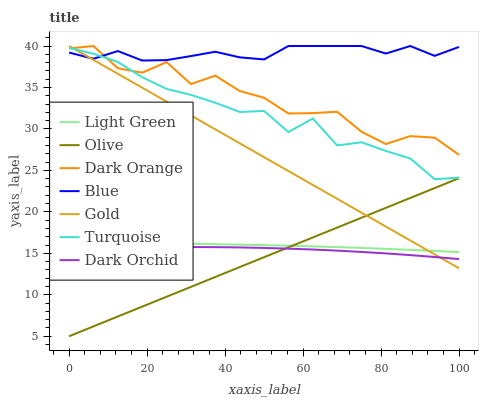Does Olive have the minimum area under the curve?
Answer yes or no. Yes. Does Blue have the maximum area under the curve?
Answer yes or no. Yes. Does Dark Orange have the minimum area under the curve?
Answer yes or no. No. Does Dark Orange have the maximum area under the curve?
Answer yes or no. No. Is Gold the smoothest?
Answer yes or no. Yes. Is Dark Orange the roughest?
Answer yes or no. Yes. Is Turquoise the smoothest?
Answer yes or no. No. Is Turquoise the roughest?
Answer yes or no. No. Does Olive have the lowest value?
Answer yes or no. Yes. Does Dark Orange have the lowest value?
Answer yes or no. No. Does Gold have the highest value?
Answer yes or no. Yes. Does Turquoise have the highest value?
Answer yes or no. No. Is Dark Orchid less than Dark Orange?
Answer yes or no. Yes. Is Dark Orange greater than Dark Orchid?
Answer yes or no. Yes. Does Olive intersect Light Green?
Answer yes or no. Yes. Is Olive less than Light Green?
Answer yes or no. No. Is Olive greater than Light Green?
Answer yes or no. No. Does Dark Orchid intersect Dark Orange?
Answer yes or no. No. 